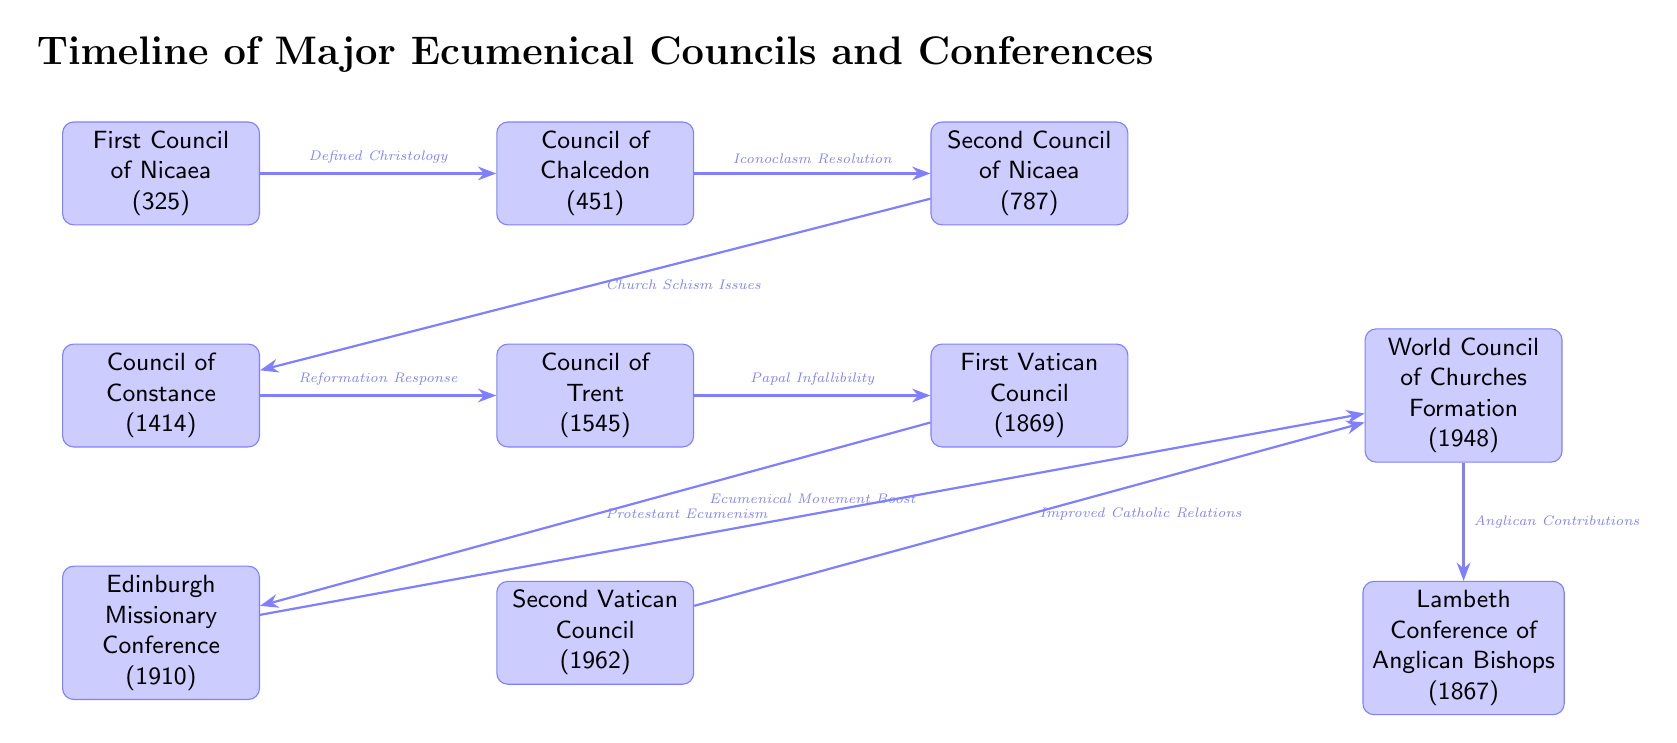What is the earliest ecumenical council listed in the diagram? The diagram shows a timeline, and the first event listed at the leftmost position is the First Council of Nicaea in 325.
Answer: First Council of Nicaea (325) How many ecumenical councils are represented in the diagram? By counting the events shown in the diagram, there are a total of six councils listed: First Council of Nicaea, Council of Chalcedon, Second Council of Nicaea, Council of Constance, Council of Trent, and First Vatican Council.
Answer: 6 What significant event occurred in 1910, according to the diagram? The diagram indicates that the Edinburgh Missionary Conference took place in 1910, and is shown below the Council of Constance.
Answer: Edinburgh Missionary Conference (1910) Which council is associated with the resolution of iconoclasm? According to the connections in the diagram, the Council of Chalcedon, which occurs after the First Council of Nicaea, is noted for the resolution of iconoclasm.
Answer: Council of Chalcedon (451) Between which two events is the phrase "Ecumenical Movement Boost" located? The connection labeled "Ecumenical Movement Boost" is between the Edinburgh Missionary Conference (1910) and the World Council of Churches Formation (1948) events.
Answer: Edinburgh Missionary Conference (1910) and World Council of Churches Formation (1948) What topic is associated with the connection from the First Vatican Council? The connection from the First Vatican Council leads to the Edinburgh Missionary Conference and is labeled "Protestant Ecumenism," indicating a focus on ecumenical cooperation among Protestant denominations.
Answer: Protestant Ecumenism What does the arrow labeled "Improved Catholic Relations" connect? The arrow labeled "Improved Catholic Relations" connects the Second Vatican Council (1962) to the World Council of Churches Formation (1948), suggesting enhanced relations between Catholics and other groups.
Answer: Second Vatican Council (1962) to World Council of Churches Formation (1948) In what year did the Council of Trent take place? The diagram clearly shows that the Council of Trent is dated to 1545.
Answer: 1545 